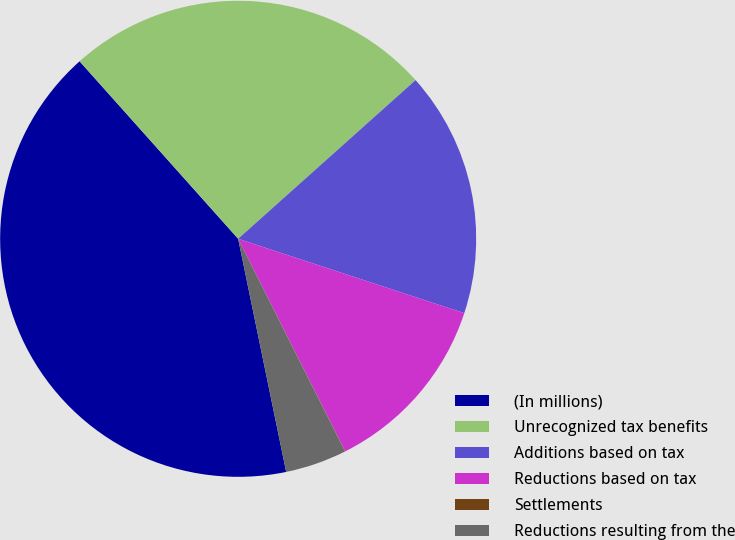Convert chart to OTSL. <chart><loc_0><loc_0><loc_500><loc_500><pie_chart><fcel>(In millions)<fcel>Unrecognized tax benefits<fcel>Additions based on tax<fcel>Reductions based on tax<fcel>Settlements<fcel>Reductions resulting from the<nl><fcel>41.63%<fcel>24.99%<fcel>16.67%<fcel>12.51%<fcel>0.02%<fcel>4.18%<nl></chart> 